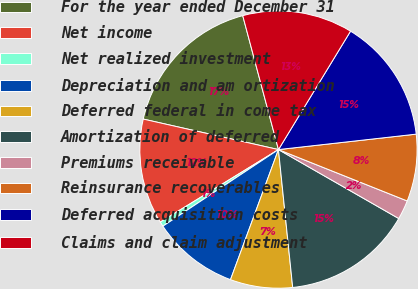<chart> <loc_0><loc_0><loc_500><loc_500><pie_chart><fcel>For the year ended December 31<fcel>Net income<fcel>Net realized investment<fcel>Depreciation and am ortization<fcel>Deferred federal in come tax<fcel>Amortization of deferred<fcel>Premiums receivable<fcel>Reinsurance recoverables<fcel>Deferred acquisition costs<fcel>Claims and claim adjustment<nl><fcel>17.32%<fcel>12.29%<fcel>0.56%<fcel>10.06%<fcel>7.26%<fcel>15.08%<fcel>2.24%<fcel>7.82%<fcel>14.52%<fcel>12.85%<nl></chart> 